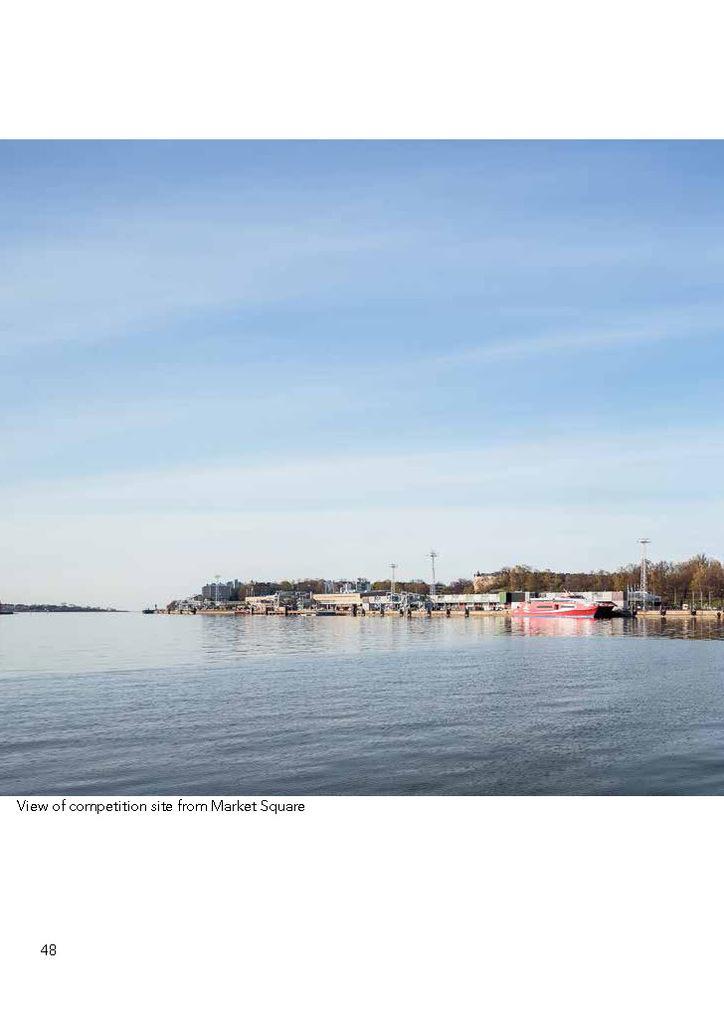Please provide a concise description of this image. In this picture we can see the water, boats, poles, trees, some objects and in the background we can see the sky and at the bottom left corner of this picture we can see some text. 